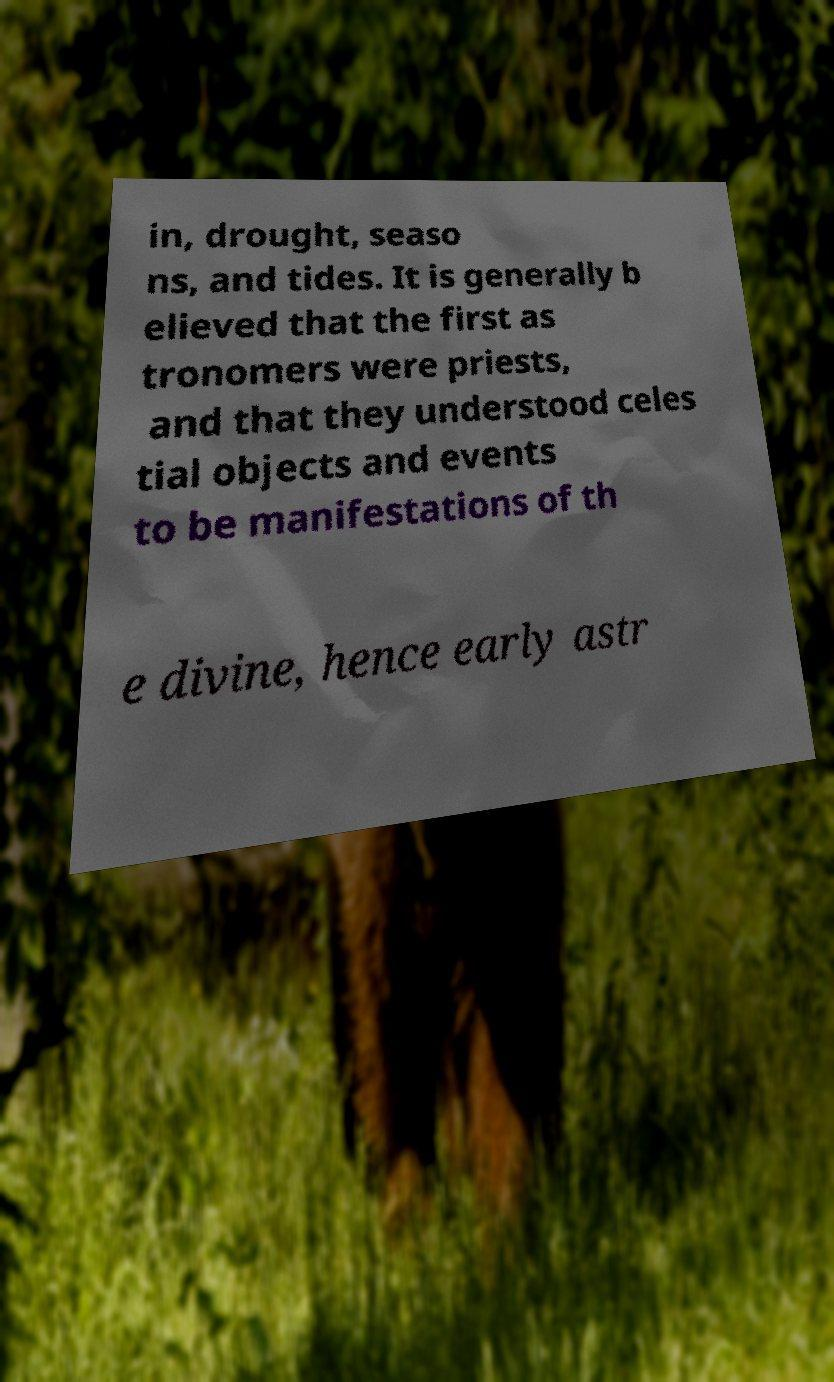Could you extract and type out the text from this image? in, drought, seaso ns, and tides. It is generally b elieved that the first as tronomers were priests, and that they understood celes tial objects and events to be manifestations of th e divine, hence early astr 